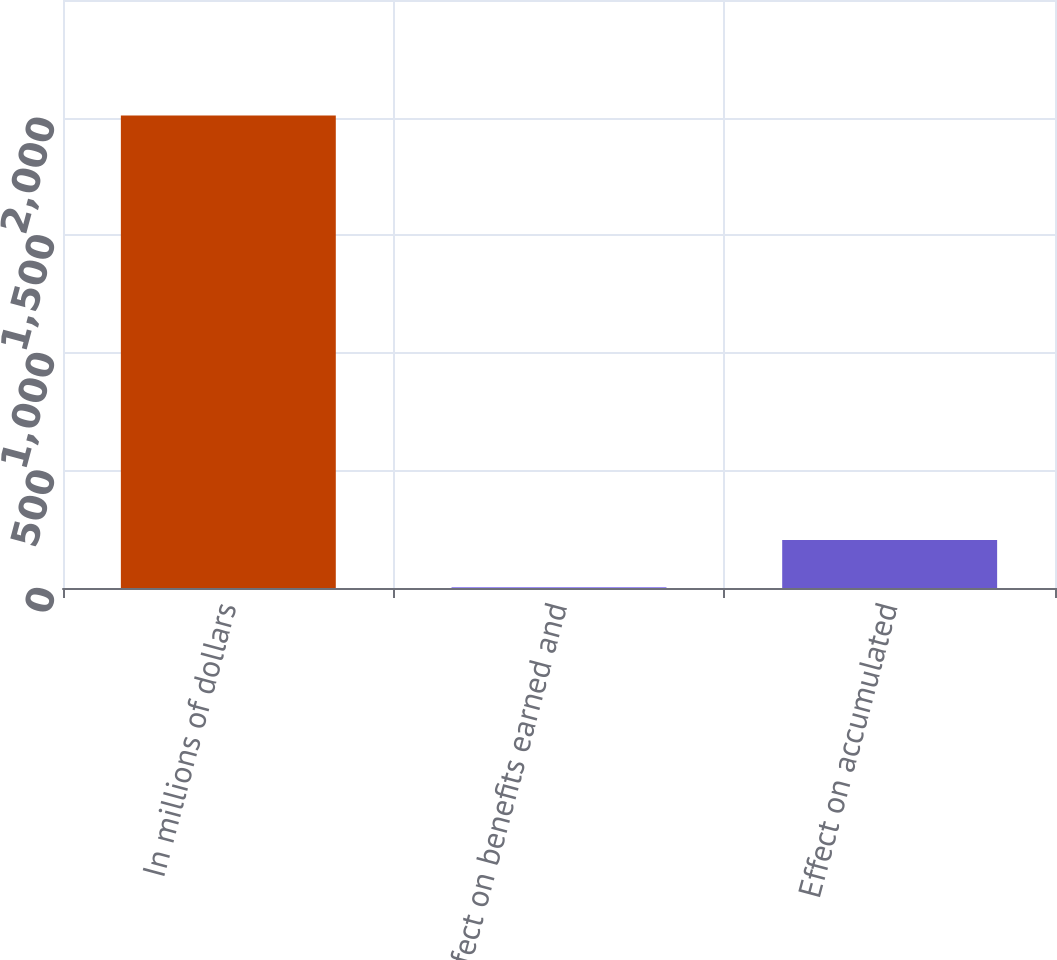<chart> <loc_0><loc_0><loc_500><loc_500><bar_chart><fcel>In millions of dollars<fcel>Effect on benefits earned and<fcel>Effect on accumulated<nl><fcel>2009<fcel>3<fcel>203.6<nl></chart> 